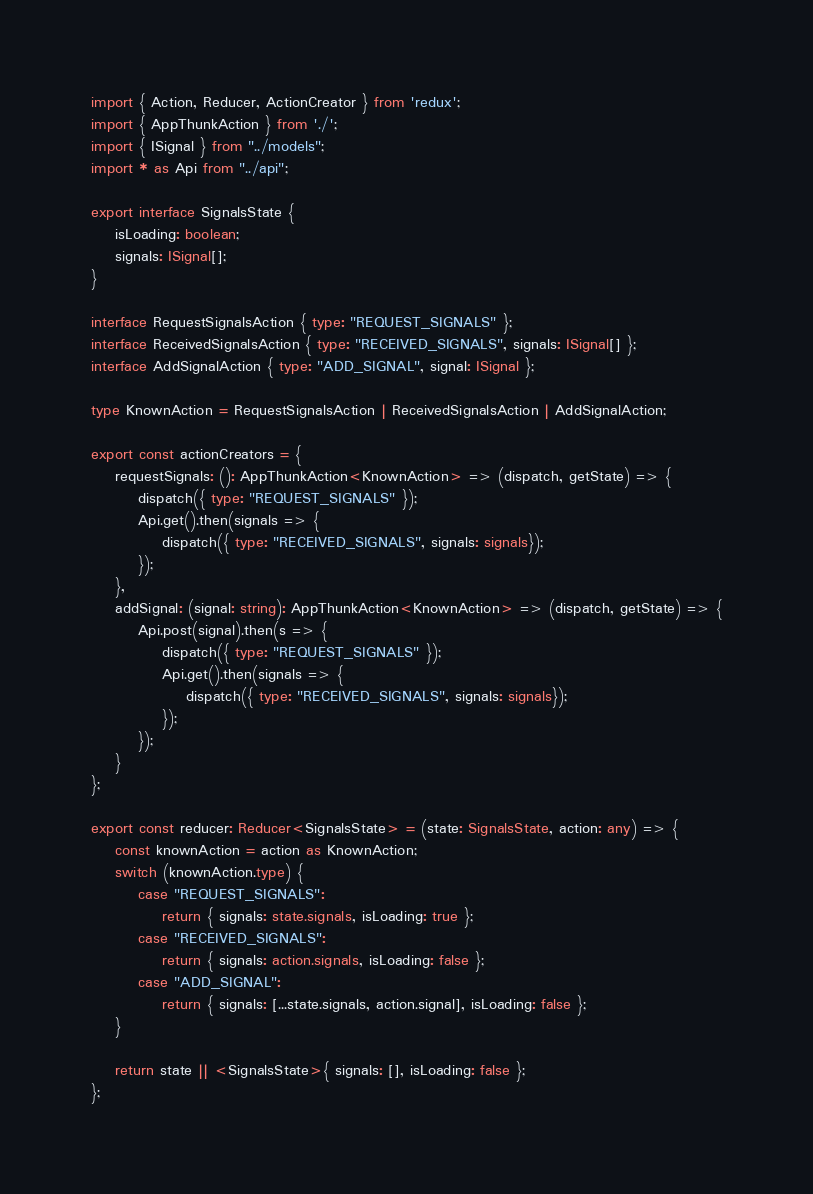<code> <loc_0><loc_0><loc_500><loc_500><_TypeScript_>import { Action, Reducer, ActionCreator } from 'redux';
import { AppThunkAction } from './';
import { ISignal } from "../models";
import * as Api from "../api";

export interface SignalsState {
    isLoading: boolean;
    signals: ISignal[];
}

interface RequestSignalsAction { type: "REQUEST_SIGNALS" };
interface ReceivedSignalsAction { type: "RECEIVED_SIGNALS", signals: ISignal[] };
interface AddSignalAction { type: "ADD_SIGNAL", signal: ISignal };

type KnownAction = RequestSignalsAction | ReceivedSignalsAction | AddSignalAction;

export const actionCreators = {
    requestSignals: (): AppThunkAction<KnownAction> => (dispatch, getState) => {
        dispatch({ type: "REQUEST_SIGNALS" });
        Api.get().then(signals => {
            dispatch({ type: "RECEIVED_SIGNALS", signals: signals});
        });
    },
    addSignal: (signal: string): AppThunkAction<KnownAction> => (dispatch, getState) => {
        Api.post(signal).then(s => {
            dispatch({ type: "REQUEST_SIGNALS" });
            Api.get().then(signals => {
                dispatch({ type: "RECEIVED_SIGNALS", signals: signals});
            });
        });
    }
};

export const reducer: Reducer<SignalsState> = (state: SignalsState, action: any) => {
    const knownAction = action as KnownAction;
    switch (knownAction.type) {
        case "REQUEST_SIGNALS":
            return { signals: state.signals, isLoading: true };
        case "RECEIVED_SIGNALS":
            return { signals: action.signals, isLoading: false };
        case "ADD_SIGNAL":
            return { signals: [...state.signals, action.signal], isLoading: false };
    }

    return state || <SignalsState>{ signals: [], isLoading: false };
};
</code> 